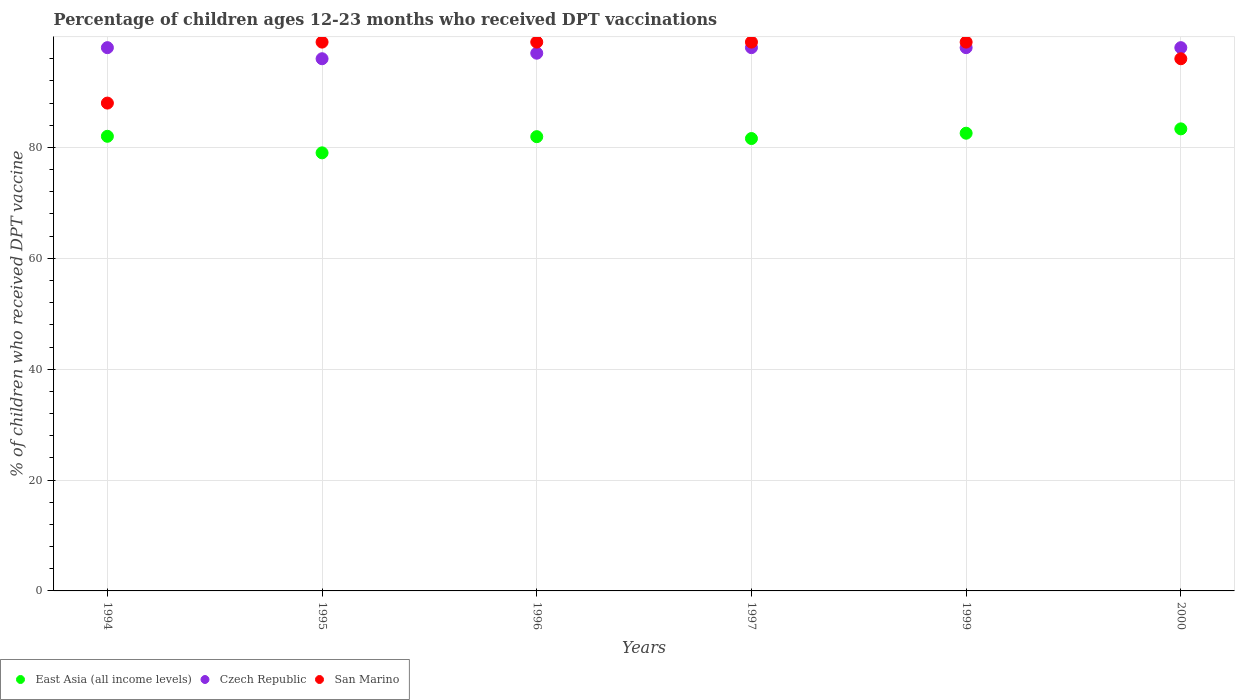Is the number of dotlines equal to the number of legend labels?
Ensure brevity in your answer.  Yes. Across all years, what is the maximum percentage of children who received DPT vaccination in East Asia (all income levels)?
Provide a short and direct response. 83.35. Across all years, what is the minimum percentage of children who received DPT vaccination in Czech Republic?
Keep it short and to the point. 96. In which year was the percentage of children who received DPT vaccination in East Asia (all income levels) maximum?
Your response must be concise. 2000. What is the total percentage of children who received DPT vaccination in Czech Republic in the graph?
Keep it short and to the point. 585. What is the difference between the percentage of children who received DPT vaccination in San Marino in 1994 and the percentage of children who received DPT vaccination in East Asia (all income levels) in 1999?
Offer a terse response. 5.43. What is the average percentage of children who received DPT vaccination in Czech Republic per year?
Your answer should be compact. 97.5. In how many years, is the percentage of children who received DPT vaccination in San Marino greater than 76 %?
Keep it short and to the point. 6. What is the ratio of the percentage of children who received DPT vaccination in San Marino in 1995 to that in 2000?
Offer a terse response. 1.03. Is the difference between the percentage of children who received DPT vaccination in San Marino in 1994 and 1996 greater than the difference between the percentage of children who received DPT vaccination in Czech Republic in 1994 and 1996?
Offer a terse response. No. What is the difference between the highest and the lowest percentage of children who received DPT vaccination in Czech Republic?
Provide a short and direct response. 2. Is the sum of the percentage of children who received DPT vaccination in San Marino in 1996 and 1999 greater than the maximum percentage of children who received DPT vaccination in Czech Republic across all years?
Provide a succinct answer. Yes. Does the percentage of children who received DPT vaccination in San Marino monotonically increase over the years?
Provide a short and direct response. No. Is the percentage of children who received DPT vaccination in San Marino strictly greater than the percentage of children who received DPT vaccination in Czech Republic over the years?
Your answer should be compact. No. How many dotlines are there?
Make the answer very short. 3. Are the values on the major ticks of Y-axis written in scientific E-notation?
Offer a very short reply. No. How many legend labels are there?
Provide a short and direct response. 3. How are the legend labels stacked?
Give a very brief answer. Horizontal. What is the title of the graph?
Provide a succinct answer. Percentage of children ages 12-23 months who received DPT vaccinations. What is the label or title of the X-axis?
Ensure brevity in your answer.  Years. What is the label or title of the Y-axis?
Your answer should be very brief. % of children who received DPT vaccine. What is the % of children who received DPT vaccine of East Asia (all income levels) in 1994?
Ensure brevity in your answer.  82.01. What is the % of children who received DPT vaccine in East Asia (all income levels) in 1995?
Give a very brief answer. 79.02. What is the % of children who received DPT vaccine in Czech Republic in 1995?
Provide a short and direct response. 96. What is the % of children who received DPT vaccine of San Marino in 1995?
Ensure brevity in your answer.  99. What is the % of children who received DPT vaccine of East Asia (all income levels) in 1996?
Offer a terse response. 81.94. What is the % of children who received DPT vaccine of Czech Republic in 1996?
Offer a terse response. 97. What is the % of children who received DPT vaccine of San Marino in 1996?
Your response must be concise. 99. What is the % of children who received DPT vaccine in East Asia (all income levels) in 1997?
Keep it short and to the point. 81.61. What is the % of children who received DPT vaccine in East Asia (all income levels) in 1999?
Provide a succinct answer. 82.57. What is the % of children who received DPT vaccine in Czech Republic in 1999?
Make the answer very short. 98. What is the % of children who received DPT vaccine in San Marino in 1999?
Ensure brevity in your answer.  99. What is the % of children who received DPT vaccine of East Asia (all income levels) in 2000?
Provide a short and direct response. 83.35. What is the % of children who received DPT vaccine in Czech Republic in 2000?
Ensure brevity in your answer.  98. What is the % of children who received DPT vaccine of San Marino in 2000?
Keep it short and to the point. 96. Across all years, what is the maximum % of children who received DPT vaccine in East Asia (all income levels)?
Provide a succinct answer. 83.35. Across all years, what is the minimum % of children who received DPT vaccine of East Asia (all income levels)?
Ensure brevity in your answer.  79.02. Across all years, what is the minimum % of children who received DPT vaccine of Czech Republic?
Provide a short and direct response. 96. Across all years, what is the minimum % of children who received DPT vaccine in San Marino?
Keep it short and to the point. 88. What is the total % of children who received DPT vaccine in East Asia (all income levels) in the graph?
Provide a short and direct response. 490.5. What is the total % of children who received DPT vaccine in Czech Republic in the graph?
Your answer should be very brief. 585. What is the total % of children who received DPT vaccine in San Marino in the graph?
Ensure brevity in your answer.  580. What is the difference between the % of children who received DPT vaccine in East Asia (all income levels) in 1994 and that in 1995?
Your answer should be very brief. 2.99. What is the difference between the % of children who received DPT vaccine in San Marino in 1994 and that in 1995?
Give a very brief answer. -11. What is the difference between the % of children who received DPT vaccine in East Asia (all income levels) in 1994 and that in 1996?
Your response must be concise. 0.07. What is the difference between the % of children who received DPT vaccine in East Asia (all income levels) in 1994 and that in 1997?
Provide a succinct answer. 0.4. What is the difference between the % of children who received DPT vaccine in San Marino in 1994 and that in 1997?
Offer a very short reply. -11. What is the difference between the % of children who received DPT vaccine in East Asia (all income levels) in 1994 and that in 1999?
Give a very brief answer. -0.56. What is the difference between the % of children who received DPT vaccine of San Marino in 1994 and that in 1999?
Offer a terse response. -11. What is the difference between the % of children who received DPT vaccine of East Asia (all income levels) in 1994 and that in 2000?
Provide a succinct answer. -1.34. What is the difference between the % of children who received DPT vaccine in Czech Republic in 1994 and that in 2000?
Ensure brevity in your answer.  0. What is the difference between the % of children who received DPT vaccine in San Marino in 1994 and that in 2000?
Keep it short and to the point. -8. What is the difference between the % of children who received DPT vaccine in East Asia (all income levels) in 1995 and that in 1996?
Your answer should be very brief. -2.92. What is the difference between the % of children who received DPT vaccine of Czech Republic in 1995 and that in 1996?
Your response must be concise. -1. What is the difference between the % of children who received DPT vaccine in San Marino in 1995 and that in 1996?
Offer a very short reply. 0. What is the difference between the % of children who received DPT vaccine of East Asia (all income levels) in 1995 and that in 1997?
Make the answer very short. -2.58. What is the difference between the % of children who received DPT vaccine of Czech Republic in 1995 and that in 1997?
Keep it short and to the point. -2. What is the difference between the % of children who received DPT vaccine of East Asia (all income levels) in 1995 and that in 1999?
Your answer should be compact. -3.54. What is the difference between the % of children who received DPT vaccine in East Asia (all income levels) in 1995 and that in 2000?
Your answer should be very brief. -4.33. What is the difference between the % of children who received DPT vaccine of Czech Republic in 1995 and that in 2000?
Provide a short and direct response. -2. What is the difference between the % of children who received DPT vaccine of East Asia (all income levels) in 1996 and that in 1997?
Provide a succinct answer. 0.34. What is the difference between the % of children who received DPT vaccine in Czech Republic in 1996 and that in 1997?
Your answer should be very brief. -1. What is the difference between the % of children who received DPT vaccine of San Marino in 1996 and that in 1997?
Your response must be concise. 0. What is the difference between the % of children who received DPT vaccine of East Asia (all income levels) in 1996 and that in 1999?
Make the answer very short. -0.62. What is the difference between the % of children who received DPT vaccine in San Marino in 1996 and that in 1999?
Give a very brief answer. 0. What is the difference between the % of children who received DPT vaccine of East Asia (all income levels) in 1996 and that in 2000?
Offer a terse response. -1.41. What is the difference between the % of children who received DPT vaccine of Czech Republic in 1996 and that in 2000?
Make the answer very short. -1. What is the difference between the % of children who received DPT vaccine of San Marino in 1996 and that in 2000?
Your answer should be very brief. 3. What is the difference between the % of children who received DPT vaccine in East Asia (all income levels) in 1997 and that in 1999?
Provide a short and direct response. -0.96. What is the difference between the % of children who received DPT vaccine in East Asia (all income levels) in 1997 and that in 2000?
Your answer should be very brief. -1.74. What is the difference between the % of children who received DPT vaccine in Czech Republic in 1997 and that in 2000?
Offer a very short reply. 0. What is the difference between the % of children who received DPT vaccine of East Asia (all income levels) in 1999 and that in 2000?
Offer a very short reply. -0.78. What is the difference between the % of children who received DPT vaccine in East Asia (all income levels) in 1994 and the % of children who received DPT vaccine in Czech Republic in 1995?
Make the answer very short. -13.99. What is the difference between the % of children who received DPT vaccine in East Asia (all income levels) in 1994 and the % of children who received DPT vaccine in San Marino in 1995?
Make the answer very short. -16.99. What is the difference between the % of children who received DPT vaccine of East Asia (all income levels) in 1994 and the % of children who received DPT vaccine of Czech Republic in 1996?
Provide a short and direct response. -14.99. What is the difference between the % of children who received DPT vaccine in East Asia (all income levels) in 1994 and the % of children who received DPT vaccine in San Marino in 1996?
Ensure brevity in your answer.  -16.99. What is the difference between the % of children who received DPT vaccine of East Asia (all income levels) in 1994 and the % of children who received DPT vaccine of Czech Republic in 1997?
Provide a short and direct response. -15.99. What is the difference between the % of children who received DPT vaccine of East Asia (all income levels) in 1994 and the % of children who received DPT vaccine of San Marino in 1997?
Offer a terse response. -16.99. What is the difference between the % of children who received DPT vaccine in Czech Republic in 1994 and the % of children who received DPT vaccine in San Marino in 1997?
Your answer should be compact. -1. What is the difference between the % of children who received DPT vaccine of East Asia (all income levels) in 1994 and the % of children who received DPT vaccine of Czech Republic in 1999?
Your answer should be very brief. -15.99. What is the difference between the % of children who received DPT vaccine in East Asia (all income levels) in 1994 and the % of children who received DPT vaccine in San Marino in 1999?
Offer a very short reply. -16.99. What is the difference between the % of children who received DPT vaccine in East Asia (all income levels) in 1994 and the % of children who received DPT vaccine in Czech Republic in 2000?
Offer a very short reply. -15.99. What is the difference between the % of children who received DPT vaccine of East Asia (all income levels) in 1994 and the % of children who received DPT vaccine of San Marino in 2000?
Provide a succinct answer. -13.99. What is the difference between the % of children who received DPT vaccine of Czech Republic in 1994 and the % of children who received DPT vaccine of San Marino in 2000?
Your answer should be very brief. 2. What is the difference between the % of children who received DPT vaccine of East Asia (all income levels) in 1995 and the % of children who received DPT vaccine of Czech Republic in 1996?
Your answer should be very brief. -17.98. What is the difference between the % of children who received DPT vaccine of East Asia (all income levels) in 1995 and the % of children who received DPT vaccine of San Marino in 1996?
Your answer should be very brief. -19.98. What is the difference between the % of children who received DPT vaccine in Czech Republic in 1995 and the % of children who received DPT vaccine in San Marino in 1996?
Provide a short and direct response. -3. What is the difference between the % of children who received DPT vaccine of East Asia (all income levels) in 1995 and the % of children who received DPT vaccine of Czech Republic in 1997?
Offer a terse response. -18.98. What is the difference between the % of children who received DPT vaccine of East Asia (all income levels) in 1995 and the % of children who received DPT vaccine of San Marino in 1997?
Ensure brevity in your answer.  -19.98. What is the difference between the % of children who received DPT vaccine of Czech Republic in 1995 and the % of children who received DPT vaccine of San Marino in 1997?
Your answer should be very brief. -3. What is the difference between the % of children who received DPT vaccine in East Asia (all income levels) in 1995 and the % of children who received DPT vaccine in Czech Republic in 1999?
Your answer should be very brief. -18.98. What is the difference between the % of children who received DPT vaccine in East Asia (all income levels) in 1995 and the % of children who received DPT vaccine in San Marino in 1999?
Offer a terse response. -19.98. What is the difference between the % of children who received DPT vaccine of East Asia (all income levels) in 1995 and the % of children who received DPT vaccine of Czech Republic in 2000?
Your response must be concise. -18.98. What is the difference between the % of children who received DPT vaccine of East Asia (all income levels) in 1995 and the % of children who received DPT vaccine of San Marino in 2000?
Your answer should be compact. -16.98. What is the difference between the % of children who received DPT vaccine in East Asia (all income levels) in 1996 and the % of children who received DPT vaccine in Czech Republic in 1997?
Ensure brevity in your answer.  -16.06. What is the difference between the % of children who received DPT vaccine of East Asia (all income levels) in 1996 and the % of children who received DPT vaccine of San Marino in 1997?
Make the answer very short. -17.06. What is the difference between the % of children who received DPT vaccine in Czech Republic in 1996 and the % of children who received DPT vaccine in San Marino in 1997?
Provide a short and direct response. -2. What is the difference between the % of children who received DPT vaccine of East Asia (all income levels) in 1996 and the % of children who received DPT vaccine of Czech Republic in 1999?
Provide a succinct answer. -16.06. What is the difference between the % of children who received DPT vaccine of East Asia (all income levels) in 1996 and the % of children who received DPT vaccine of San Marino in 1999?
Make the answer very short. -17.06. What is the difference between the % of children who received DPT vaccine of East Asia (all income levels) in 1996 and the % of children who received DPT vaccine of Czech Republic in 2000?
Your answer should be very brief. -16.06. What is the difference between the % of children who received DPT vaccine in East Asia (all income levels) in 1996 and the % of children who received DPT vaccine in San Marino in 2000?
Ensure brevity in your answer.  -14.06. What is the difference between the % of children who received DPT vaccine in East Asia (all income levels) in 1997 and the % of children who received DPT vaccine in Czech Republic in 1999?
Offer a terse response. -16.39. What is the difference between the % of children who received DPT vaccine in East Asia (all income levels) in 1997 and the % of children who received DPT vaccine in San Marino in 1999?
Offer a very short reply. -17.39. What is the difference between the % of children who received DPT vaccine of Czech Republic in 1997 and the % of children who received DPT vaccine of San Marino in 1999?
Offer a terse response. -1. What is the difference between the % of children who received DPT vaccine in East Asia (all income levels) in 1997 and the % of children who received DPT vaccine in Czech Republic in 2000?
Make the answer very short. -16.39. What is the difference between the % of children who received DPT vaccine of East Asia (all income levels) in 1997 and the % of children who received DPT vaccine of San Marino in 2000?
Give a very brief answer. -14.39. What is the difference between the % of children who received DPT vaccine of East Asia (all income levels) in 1999 and the % of children who received DPT vaccine of Czech Republic in 2000?
Your answer should be very brief. -15.43. What is the difference between the % of children who received DPT vaccine of East Asia (all income levels) in 1999 and the % of children who received DPT vaccine of San Marino in 2000?
Give a very brief answer. -13.43. What is the difference between the % of children who received DPT vaccine of Czech Republic in 1999 and the % of children who received DPT vaccine of San Marino in 2000?
Offer a very short reply. 2. What is the average % of children who received DPT vaccine in East Asia (all income levels) per year?
Keep it short and to the point. 81.75. What is the average % of children who received DPT vaccine in Czech Republic per year?
Offer a very short reply. 97.5. What is the average % of children who received DPT vaccine of San Marino per year?
Provide a succinct answer. 96.67. In the year 1994, what is the difference between the % of children who received DPT vaccine of East Asia (all income levels) and % of children who received DPT vaccine of Czech Republic?
Your answer should be very brief. -15.99. In the year 1994, what is the difference between the % of children who received DPT vaccine in East Asia (all income levels) and % of children who received DPT vaccine in San Marino?
Provide a short and direct response. -5.99. In the year 1994, what is the difference between the % of children who received DPT vaccine in Czech Republic and % of children who received DPT vaccine in San Marino?
Offer a very short reply. 10. In the year 1995, what is the difference between the % of children who received DPT vaccine in East Asia (all income levels) and % of children who received DPT vaccine in Czech Republic?
Provide a succinct answer. -16.98. In the year 1995, what is the difference between the % of children who received DPT vaccine in East Asia (all income levels) and % of children who received DPT vaccine in San Marino?
Offer a very short reply. -19.98. In the year 1996, what is the difference between the % of children who received DPT vaccine in East Asia (all income levels) and % of children who received DPT vaccine in Czech Republic?
Keep it short and to the point. -15.06. In the year 1996, what is the difference between the % of children who received DPT vaccine in East Asia (all income levels) and % of children who received DPT vaccine in San Marino?
Offer a very short reply. -17.06. In the year 1997, what is the difference between the % of children who received DPT vaccine in East Asia (all income levels) and % of children who received DPT vaccine in Czech Republic?
Your response must be concise. -16.39. In the year 1997, what is the difference between the % of children who received DPT vaccine of East Asia (all income levels) and % of children who received DPT vaccine of San Marino?
Ensure brevity in your answer.  -17.39. In the year 1997, what is the difference between the % of children who received DPT vaccine of Czech Republic and % of children who received DPT vaccine of San Marino?
Keep it short and to the point. -1. In the year 1999, what is the difference between the % of children who received DPT vaccine in East Asia (all income levels) and % of children who received DPT vaccine in Czech Republic?
Keep it short and to the point. -15.43. In the year 1999, what is the difference between the % of children who received DPT vaccine in East Asia (all income levels) and % of children who received DPT vaccine in San Marino?
Provide a succinct answer. -16.43. In the year 1999, what is the difference between the % of children who received DPT vaccine in Czech Republic and % of children who received DPT vaccine in San Marino?
Ensure brevity in your answer.  -1. In the year 2000, what is the difference between the % of children who received DPT vaccine of East Asia (all income levels) and % of children who received DPT vaccine of Czech Republic?
Give a very brief answer. -14.65. In the year 2000, what is the difference between the % of children who received DPT vaccine of East Asia (all income levels) and % of children who received DPT vaccine of San Marino?
Offer a very short reply. -12.65. What is the ratio of the % of children who received DPT vaccine in East Asia (all income levels) in 1994 to that in 1995?
Provide a short and direct response. 1.04. What is the ratio of the % of children who received DPT vaccine of Czech Republic in 1994 to that in 1995?
Your answer should be very brief. 1.02. What is the ratio of the % of children who received DPT vaccine of Czech Republic in 1994 to that in 1996?
Offer a very short reply. 1.01. What is the ratio of the % of children who received DPT vaccine of Czech Republic in 1994 to that in 1997?
Give a very brief answer. 1. What is the ratio of the % of children who received DPT vaccine of San Marino in 1994 to that in 1997?
Make the answer very short. 0.89. What is the ratio of the % of children who received DPT vaccine in East Asia (all income levels) in 1994 to that in 1999?
Your answer should be very brief. 0.99. What is the ratio of the % of children who received DPT vaccine in San Marino in 1994 to that in 1999?
Keep it short and to the point. 0.89. What is the ratio of the % of children who received DPT vaccine in East Asia (all income levels) in 1994 to that in 2000?
Provide a succinct answer. 0.98. What is the ratio of the % of children who received DPT vaccine of Czech Republic in 1994 to that in 2000?
Ensure brevity in your answer.  1. What is the ratio of the % of children who received DPT vaccine of East Asia (all income levels) in 1995 to that in 1996?
Provide a short and direct response. 0.96. What is the ratio of the % of children who received DPT vaccine of Czech Republic in 1995 to that in 1996?
Make the answer very short. 0.99. What is the ratio of the % of children who received DPT vaccine of San Marino in 1995 to that in 1996?
Offer a terse response. 1. What is the ratio of the % of children who received DPT vaccine in East Asia (all income levels) in 1995 to that in 1997?
Provide a succinct answer. 0.97. What is the ratio of the % of children who received DPT vaccine in Czech Republic in 1995 to that in 1997?
Make the answer very short. 0.98. What is the ratio of the % of children who received DPT vaccine in San Marino in 1995 to that in 1997?
Provide a short and direct response. 1. What is the ratio of the % of children who received DPT vaccine of East Asia (all income levels) in 1995 to that in 1999?
Your response must be concise. 0.96. What is the ratio of the % of children who received DPT vaccine of Czech Republic in 1995 to that in 1999?
Keep it short and to the point. 0.98. What is the ratio of the % of children who received DPT vaccine in East Asia (all income levels) in 1995 to that in 2000?
Ensure brevity in your answer.  0.95. What is the ratio of the % of children who received DPT vaccine in Czech Republic in 1995 to that in 2000?
Keep it short and to the point. 0.98. What is the ratio of the % of children who received DPT vaccine of San Marino in 1995 to that in 2000?
Your answer should be very brief. 1.03. What is the ratio of the % of children who received DPT vaccine of East Asia (all income levels) in 1996 to that in 1997?
Offer a terse response. 1. What is the ratio of the % of children who received DPT vaccine in Czech Republic in 1996 to that in 1997?
Keep it short and to the point. 0.99. What is the ratio of the % of children who received DPT vaccine in San Marino in 1996 to that in 1997?
Your answer should be compact. 1. What is the ratio of the % of children who received DPT vaccine in Czech Republic in 1996 to that in 1999?
Offer a terse response. 0.99. What is the ratio of the % of children who received DPT vaccine of San Marino in 1996 to that in 1999?
Offer a terse response. 1. What is the ratio of the % of children who received DPT vaccine in East Asia (all income levels) in 1996 to that in 2000?
Provide a short and direct response. 0.98. What is the ratio of the % of children who received DPT vaccine in San Marino in 1996 to that in 2000?
Offer a very short reply. 1.03. What is the ratio of the % of children who received DPT vaccine in East Asia (all income levels) in 1997 to that in 1999?
Provide a succinct answer. 0.99. What is the ratio of the % of children who received DPT vaccine of Czech Republic in 1997 to that in 1999?
Make the answer very short. 1. What is the ratio of the % of children who received DPT vaccine of East Asia (all income levels) in 1997 to that in 2000?
Keep it short and to the point. 0.98. What is the ratio of the % of children who received DPT vaccine in San Marino in 1997 to that in 2000?
Offer a very short reply. 1.03. What is the ratio of the % of children who received DPT vaccine of East Asia (all income levels) in 1999 to that in 2000?
Make the answer very short. 0.99. What is the ratio of the % of children who received DPT vaccine in Czech Republic in 1999 to that in 2000?
Make the answer very short. 1. What is the ratio of the % of children who received DPT vaccine in San Marino in 1999 to that in 2000?
Your response must be concise. 1.03. What is the difference between the highest and the second highest % of children who received DPT vaccine in East Asia (all income levels)?
Make the answer very short. 0.78. What is the difference between the highest and the second highest % of children who received DPT vaccine in Czech Republic?
Make the answer very short. 0. What is the difference between the highest and the lowest % of children who received DPT vaccine of East Asia (all income levels)?
Your answer should be very brief. 4.33. What is the difference between the highest and the lowest % of children who received DPT vaccine of San Marino?
Give a very brief answer. 11. 